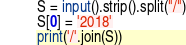<code> <loc_0><loc_0><loc_500><loc_500><_Python_>S = input().strip().split("/")
S[0] = '2018'
print('/'.join(S))
</code> 